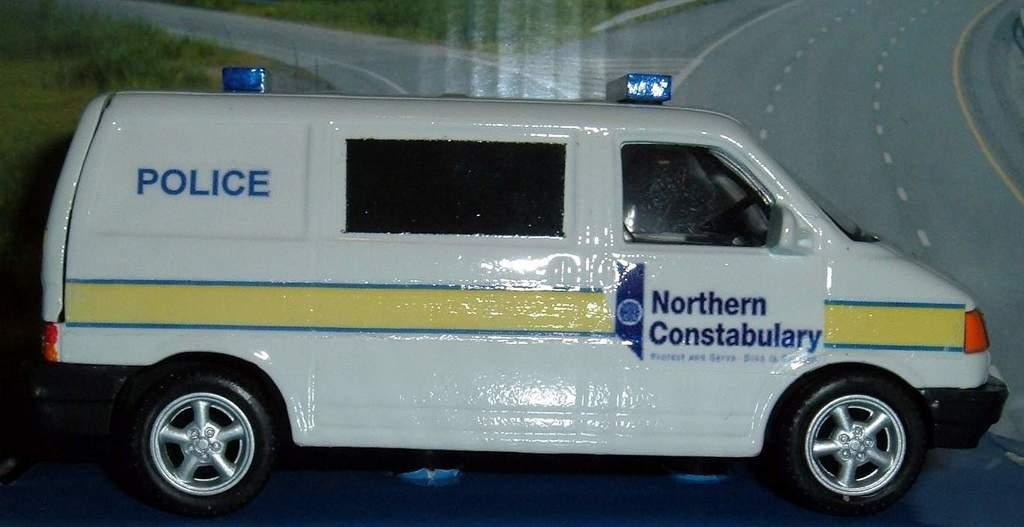<image>
Give a short and clear explanation of the subsequent image. Northern Costabulary is written on the side door of the van. 